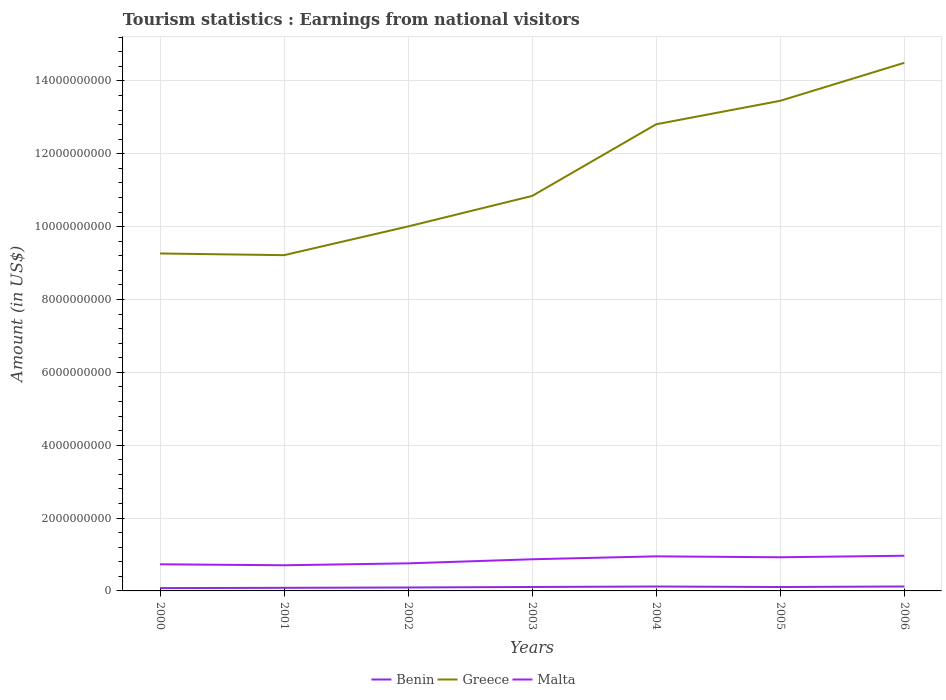Does the line corresponding to Malta intersect with the line corresponding to Benin?
Offer a terse response. No. Across all years, what is the maximum earnings from national visitors in Greece?
Provide a short and direct response. 9.22e+09. In which year was the earnings from national visitors in Benin maximum?
Provide a short and direct response. 2000. What is the total earnings from national visitors in Benin in the graph?
Your answer should be very brief. -3.61e+07. What is the difference between the highest and the second highest earnings from national visitors in Benin?
Your response must be concise. 4.42e+07. What is the difference between the highest and the lowest earnings from national visitors in Malta?
Your answer should be compact. 4. How many years are there in the graph?
Give a very brief answer. 7. What is the difference between two consecutive major ticks on the Y-axis?
Offer a terse response. 2.00e+09. Are the values on the major ticks of Y-axis written in scientific E-notation?
Make the answer very short. No. Does the graph contain any zero values?
Give a very brief answer. No. How many legend labels are there?
Offer a very short reply. 3. How are the legend labels stacked?
Your response must be concise. Horizontal. What is the title of the graph?
Provide a succinct answer. Tourism statistics : Earnings from national visitors. What is the label or title of the X-axis?
Keep it short and to the point. Years. What is the Amount (in US$) in Benin in 2000?
Offer a very short reply. 7.74e+07. What is the Amount (in US$) of Greece in 2000?
Offer a terse response. 9.26e+09. What is the Amount (in US$) of Malta in 2000?
Keep it short and to the point. 7.31e+08. What is the Amount (in US$) in Benin in 2001?
Provide a short and direct response. 8.55e+07. What is the Amount (in US$) of Greece in 2001?
Your response must be concise. 9.22e+09. What is the Amount (in US$) in Malta in 2001?
Ensure brevity in your answer.  7.04e+08. What is the Amount (in US$) of Benin in 2002?
Make the answer very short. 9.45e+07. What is the Amount (in US$) in Greece in 2002?
Make the answer very short. 1.00e+1. What is the Amount (in US$) in Malta in 2002?
Your answer should be very brief. 7.57e+08. What is the Amount (in US$) in Benin in 2003?
Your answer should be very brief. 1.08e+08. What is the Amount (in US$) of Greece in 2003?
Give a very brief answer. 1.08e+1. What is the Amount (in US$) in Malta in 2003?
Make the answer very short. 8.69e+08. What is the Amount (in US$) in Benin in 2004?
Give a very brief answer. 1.21e+08. What is the Amount (in US$) of Greece in 2004?
Your answer should be compact. 1.28e+1. What is the Amount (in US$) in Malta in 2004?
Provide a succinct answer. 9.49e+08. What is the Amount (in US$) in Benin in 2005?
Make the answer very short. 1.08e+08. What is the Amount (in US$) in Greece in 2005?
Your response must be concise. 1.35e+1. What is the Amount (in US$) of Malta in 2005?
Offer a very short reply. 9.24e+08. What is the Amount (in US$) in Benin in 2006?
Your answer should be compact. 1.22e+08. What is the Amount (in US$) of Greece in 2006?
Provide a succinct answer. 1.45e+1. What is the Amount (in US$) of Malta in 2006?
Offer a terse response. 9.66e+08. Across all years, what is the maximum Amount (in US$) in Benin?
Ensure brevity in your answer.  1.22e+08. Across all years, what is the maximum Amount (in US$) in Greece?
Your answer should be compact. 1.45e+1. Across all years, what is the maximum Amount (in US$) of Malta?
Make the answer very short. 9.66e+08. Across all years, what is the minimum Amount (in US$) of Benin?
Your answer should be very brief. 7.74e+07. Across all years, what is the minimum Amount (in US$) of Greece?
Your response must be concise. 9.22e+09. Across all years, what is the minimum Amount (in US$) in Malta?
Ensure brevity in your answer.  7.04e+08. What is the total Amount (in US$) of Benin in the graph?
Provide a succinct answer. 7.16e+08. What is the total Amount (in US$) of Greece in the graph?
Make the answer very short. 8.01e+1. What is the total Amount (in US$) of Malta in the graph?
Ensure brevity in your answer.  5.90e+09. What is the difference between the Amount (in US$) in Benin in 2000 and that in 2001?
Your response must be concise. -8.10e+06. What is the difference between the Amount (in US$) in Greece in 2000 and that in 2001?
Keep it short and to the point. 4.60e+07. What is the difference between the Amount (in US$) of Malta in 2000 and that in 2001?
Make the answer very short. 2.70e+07. What is the difference between the Amount (in US$) of Benin in 2000 and that in 2002?
Provide a succinct answer. -1.71e+07. What is the difference between the Amount (in US$) in Greece in 2000 and that in 2002?
Make the answer very short. -7.43e+08. What is the difference between the Amount (in US$) of Malta in 2000 and that in 2002?
Make the answer very short. -2.60e+07. What is the difference between the Amount (in US$) of Benin in 2000 and that in 2003?
Your answer should be very brief. -3.05e+07. What is the difference between the Amount (in US$) in Greece in 2000 and that in 2003?
Keep it short and to the point. -1.58e+09. What is the difference between the Amount (in US$) in Malta in 2000 and that in 2003?
Your answer should be compact. -1.38e+08. What is the difference between the Amount (in US$) in Benin in 2000 and that in 2004?
Offer a terse response. -4.35e+07. What is the difference between the Amount (in US$) of Greece in 2000 and that in 2004?
Provide a succinct answer. -3.55e+09. What is the difference between the Amount (in US$) in Malta in 2000 and that in 2004?
Offer a terse response. -2.18e+08. What is the difference between the Amount (in US$) in Benin in 2000 and that in 2005?
Your answer should be compact. -3.03e+07. What is the difference between the Amount (in US$) in Greece in 2000 and that in 2005?
Offer a very short reply. -4.19e+09. What is the difference between the Amount (in US$) of Malta in 2000 and that in 2005?
Keep it short and to the point. -1.93e+08. What is the difference between the Amount (in US$) of Benin in 2000 and that in 2006?
Provide a short and direct response. -4.42e+07. What is the difference between the Amount (in US$) in Greece in 2000 and that in 2006?
Make the answer very short. -5.23e+09. What is the difference between the Amount (in US$) of Malta in 2000 and that in 2006?
Provide a short and direct response. -2.35e+08. What is the difference between the Amount (in US$) of Benin in 2001 and that in 2002?
Offer a terse response. -9.00e+06. What is the difference between the Amount (in US$) in Greece in 2001 and that in 2002?
Your answer should be very brief. -7.89e+08. What is the difference between the Amount (in US$) of Malta in 2001 and that in 2002?
Offer a terse response. -5.30e+07. What is the difference between the Amount (in US$) of Benin in 2001 and that in 2003?
Your answer should be compact. -2.24e+07. What is the difference between the Amount (in US$) of Greece in 2001 and that in 2003?
Ensure brevity in your answer.  -1.63e+09. What is the difference between the Amount (in US$) in Malta in 2001 and that in 2003?
Provide a short and direct response. -1.65e+08. What is the difference between the Amount (in US$) in Benin in 2001 and that in 2004?
Offer a very short reply. -3.54e+07. What is the difference between the Amount (in US$) in Greece in 2001 and that in 2004?
Keep it short and to the point. -3.59e+09. What is the difference between the Amount (in US$) in Malta in 2001 and that in 2004?
Offer a very short reply. -2.45e+08. What is the difference between the Amount (in US$) of Benin in 2001 and that in 2005?
Your response must be concise. -2.22e+07. What is the difference between the Amount (in US$) in Greece in 2001 and that in 2005?
Your answer should be compact. -4.24e+09. What is the difference between the Amount (in US$) of Malta in 2001 and that in 2005?
Offer a terse response. -2.20e+08. What is the difference between the Amount (in US$) of Benin in 2001 and that in 2006?
Your answer should be compact. -3.61e+07. What is the difference between the Amount (in US$) in Greece in 2001 and that in 2006?
Your answer should be compact. -5.28e+09. What is the difference between the Amount (in US$) in Malta in 2001 and that in 2006?
Provide a succinct answer. -2.62e+08. What is the difference between the Amount (in US$) in Benin in 2002 and that in 2003?
Offer a terse response. -1.34e+07. What is the difference between the Amount (in US$) in Greece in 2002 and that in 2003?
Offer a very short reply. -8.37e+08. What is the difference between the Amount (in US$) in Malta in 2002 and that in 2003?
Ensure brevity in your answer.  -1.12e+08. What is the difference between the Amount (in US$) in Benin in 2002 and that in 2004?
Provide a short and direct response. -2.64e+07. What is the difference between the Amount (in US$) of Greece in 2002 and that in 2004?
Your answer should be compact. -2.80e+09. What is the difference between the Amount (in US$) in Malta in 2002 and that in 2004?
Provide a short and direct response. -1.92e+08. What is the difference between the Amount (in US$) of Benin in 2002 and that in 2005?
Provide a short and direct response. -1.32e+07. What is the difference between the Amount (in US$) of Greece in 2002 and that in 2005?
Keep it short and to the point. -3.45e+09. What is the difference between the Amount (in US$) of Malta in 2002 and that in 2005?
Your answer should be very brief. -1.67e+08. What is the difference between the Amount (in US$) in Benin in 2002 and that in 2006?
Provide a succinct answer. -2.71e+07. What is the difference between the Amount (in US$) in Greece in 2002 and that in 2006?
Your answer should be very brief. -4.49e+09. What is the difference between the Amount (in US$) in Malta in 2002 and that in 2006?
Your response must be concise. -2.09e+08. What is the difference between the Amount (in US$) of Benin in 2003 and that in 2004?
Offer a very short reply. -1.30e+07. What is the difference between the Amount (in US$) of Greece in 2003 and that in 2004?
Offer a terse response. -1.97e+09. What is the difference between the Amount (in US$) in Malta in 2003 and that in 2004?
Your answer should be compact. -8.00e+07. What is the difference between the Amount (in US$) of Greece in 2003 and that in 2005?
Give a very brief answer. -2.61e+09. What is the difference between the Amount (in US$) of Malta in 2003 and that in 2005?
Your response must be concise. -5.50e+07. What is the difference between the Amount (in US$) of Benin in 2003 and that in 2006?
Provide a short and direct response. -1.37e+07. What is the difference between the Amount (in US$) of Greece in 2003 and that in 2006?
Your answer should be compact. -3.65e+09. What is the difference between the Amount (in US$) in Malta in 2003 and that in 2006?
Provide a succinct answer. -9.70e+07. What is the difference between the Amount (in US$) of Benin in 2004 and that in 2005?
Give a very brief answer. 1.32e+07. What is the difference between the Amount (in US$) in Greece in 2004 and that in 2005?
Make the answer very short. -6.44e+08. What is the difference between the Amount (in US$) of Malta in 2004 and that in 2005?
Offer a very short reply. 2.50e+07. What is the difference between the Amount (in US$) in Benin in 2004 and that in 2006?
Your answer should be very brief. -7.00e+05. What is the difference between the Amount (in US$) of Greece in 2004 and that in 2006?
Give a very brief answer. -1.69e+09. What is the difference between the Amount (in US$) of Malta in 2004 and that in 2006?
Provide a succinct answer. -1.70e+07. What is the difference between the Amount (in US$) of Benin in 2005 and that in 2006?
Give a very brief answer. -1.39e+07. What is the difference between the Amount (in US$) in Greece in 2005 and that in 2006?
Your answer should be compact. -1.04e+09. What is the difference between the Amount (in US$) in Malta in 2005 and that in 2006?
Offer a terse response. -4.20e+07. What is the difference between the Amount (in US$) of Benin in 2000 and the Amount (in US$) of Greece in 2001?
Give a very brief answer. -9.14e+09. What is the difference between the Amount (in US$) in Benin in 2000 and the Amount (in US$) in Malta in 2001?
Offer a very short reply. -6.27e+08. What is the difference between the Amount (in US$) in Greece in 2000 and the Amount (in US$) in Malta in 2001?
Make the answer very short. 8.56e+09. What is the difference between the Amount (in US$) in Benin in 2000 and the Amount (in US$) in Greece in 2002?
Provide a short and direct response. -9.93e+09. What is the difference between the Amount (in US$) of Benin in 2000 and the Amount (in US$) of Malta in 2002?
Offer a very short reply. -6.80e+08. What is the difference between the Amount (in US$) of Greece in 2000 and the Amount (in US$) of Malta in 2002?
Provide a short and direct response. 8.50e+09. What is the difference between the Amount (in US$) of Benin in 2000 and the Amount (in US$) of Greece in 2003?
Your answer should be compact. -1.08e+1. What is the difference between the Amount (in US$) in Benin in 2000 and the Amount (in US$) in Malta in 2003?
Your answer should be very brief. -7.92e+08. What is the difference between the Amount (in US$) of Greece in 2000 and the Amount (in US$) of Malta in 2003?
Provide a succinct answer. 8.39e+09. What is the difference between the Amount (in US$) in Benin in 2000 and the Amount (in US$) in Greece in 2004?
Offer a very short reply. -1.27e+1. What is the difference between the Amount (in US$) in Benin in 2000 and the Amount (in US$) in Malta in 2004?
Offer a very short reply. -8.72e+08. What is the difference between the Amount (in US$) of Greece in 2000 and the Amount (in US$) of Malta in 2004?
Provide a short and direct response. 8.31e+09. What is the difference between the Amount (in US$) of Benin in 2000 and the Amount (in US$) of Greece in 2005?
Offer a very short reply. -1.34e+1. What is the difference between the Amount (in US$) of Benin in 2000 and the Amount (in US$) of Malta in 2005?
Give a very brief answer. -8.47e+08. What is the difference between the Amount (in US$) in Greece in 2000 and the Amount (in US$) in Malta in 2005?
Make the answer very short. 8.34e+09. What is the difference between the Amount (in US$) in Benin in 2000 and the Amount (in US$) in Greece in 2006?
Keep it short and to the point. -1.44e+1. What is the difference between the Amount (in US$) of Benin in 2000 and the Amount (in US$) of Malta in 2006?
Provide a short and direct response. -8.89e+08. What is the difference between the Amount (in US$) of Greece in 2000 and the Amount (in US$) of Malta in 2006?
Provide a short and direct response. 8.30e+09. What is the difference between the Amount (in US$) of Benin in 2001 and the Amount (in US$) of Greece in 2002?
Provide a succinct answer. -9.92e+09. What is the difference between the Amount (in US$) in Benin in 2001 and the Amount (in US$) in Malta in 2002?
Offer a terse response. -6.72e+08. What is the difference between the Amount (in US$) of Greece in 2001 and the Amount (in US$) of Malta in 2002?
Offer a very short reply. 8.46e+09. What is the difference between the Amount (in US$) of Benin in 2001 and the Amount (in US$) of Greece in 2003?
Keep it short and to the point. -1.08e+1. What is the difference between the Amount (in US$) of Benin in 2001 and the Amount (in US$) of Malta in 2003?
Provide a succinct answer. -7.84e+08. What is the difference between the Amount (in US$) of Greece in 2001 and the Amount (in US$) of Malta in 2003?
Your answer should be very brief. 8.35e+09. What is the difference between the Amount (in US$) of Benin in 2001 and the Amount (in US$) of Greece in 2004?
Offer a terse response. -1.27e+1. What is the difference between the Amount (in US$) in Benin in 2001 and the Amount (in US$) in Malta in 2004?
Give a very brief answer. -8.64e+08. What is the difference between the Amount (in US$) of Greece in 2001 and the Amount (in US$) of Malta in 2004?
Ensure brevity in your answer.  8.27e+09. What is the difference between the Amount (in US$) of Benin in 2001 and the Amount (in US$) of Greece in 2005?
Your response must be concise. -1.34e+1. What is the difference between the Amount (in US$) of Benin in 2001 and the Amount (in US$) of Malta in 2005?
Your response must be concise. -8.38e+08. What is the difference between the Amount (in US$) in Greece in 2001 and the Amount (in US$) in Malta in 2005?
Make the answer very short. 8.29e+09. What is the difference between the Amount (in US$) in Benin in 2001 and the Amount (in US$) in Greece in 2006?
Your answer should be compact. -1.44e+1. What is the difference between the Amount (in US$) of Benin in 2001 and the Amount (in US$) of Malta in 2006?
Your answer should be compact. -8.80e+08. What is the difference between the Amount (in US$) of Greece in 2001 and the Amount (in US$) of Malta in 2006?
Offer a very short reply. 8.25e+09. What is the difference between the Amount (in US$) of Benin in 2002 and the Amount (in US$) of Greece in 2003?
Ensure brevity in your answer.  -1.07e+1. What is the difference between the Amount (in US$) in Benin in 2002 and the Amount (in US$) in Malta in 2003?
Offer a terse response. -7.74e+08. What is the difference between the Amount (in US$) of Greece in 2002 and the Amount (in US$) of Malta in 2003?
Offer a very short reply. 9.14e+09. What is the difference between the Amount (in US$) of Benin in 2002 and the Amount (in US$) of Greece in 2004?
Your answer should be very brief. -1.27e+1. What is the difference between the Amount (in US$) in Benin in 2002 and the Amount (in US$) in Malta in 2004?
Offer a terse response. -8.54e+08. What is the difference between the Amount (in US$) in Greece in 2002 and the Amount (in US$) in Malta in 2004?
Make the answer very short. 9.06e+09. What is the difference between the Amount (in US$) in Benin in 2002 and the Amount (in US$) in Greece in 2005?
Make the answer very short. -1.34e+1. What is the difference between the Amount (in US$) of Benin in 2002 and the Amount (in US$) of Malta in 2005?
Provide a short and direct response. -8.30e+08. What is the difference between the Amount (in US$) of Greece in 2002 and the Amount (in US$) of Malta in 2005?
Make the answer very short. 9.08e+09. What is the difference between the Amount (in US$) in Benin in 2002 and the Amount (in US$) in Greece in 2006?
Provide a short and direct response. -1.44e+1. What is the difference between the Amount (in US$) of Benin in 2002 and the Amount (in US$) of Malta in 2006?
Keep it short and to the point. -8.72e+08. What is the difference between the Amount (in US$) of Greece in 2002 and the Amount (in US$) of Malta in 2006?
Your response must be concise. 9.04e+09. What is the difference between the Amount (in US$) of Benin in 2003 and the Amount (in US$) of Greece in 2004?
Your answer should be very brief. -1.27e+1. What is the difference between the Amount (in US$) of Benin in 2003 and the Amount (in US$) of Malta in 2004?
Your answer should be compact. -8.41e+08. What is the difference between the Amount (in US$) in Greece in 2003 and the Amount (in US$) in Malta in 2004?
Provide a succinct answer. 9.89e+09. What is the difference between the Amount (in US$) in Benin in 2003 and the Amount (in US$) in Greece in 2005?
Offer a very short reply. -1.33e+1. What is the difference between the Amount (in US$) in Benin in 2003 and the Amount (in US$) in Malta in 2005?
Provide a short and direct response. -8.16e+08. What is the difference between the Amount (in US$) of Greece in 2003 and the Amount (in US$) of Malta in 2005?
Your answer should be compact. 9.92e+09. What is the difference between the Amount (in US$) in Benin in 2003 and the Amount (in US$) in Greece in 2006?
Make the answer very short. -1.44e+1. What is the difference between the Amount (in US$) of Benin in 2003 and the Amount (in US$) of Malta in 2006?
Offer a terse response. -8.58e+08. What is the difference between the Amount (in US$) of Greece in 2003 and the Amount (in US$) of Malta in 2006?
Offer a very short reply. 9.88e+09. What is the difference between the Amount (in US$) of Benin in 2004 and the Amount (in US$) of Greece in 2005?
Keep it short and to the point. -1.33e+1. What is the difference between the Amount (in US$) in Benin in 2004 and the Amount (in US$) in Malta in 2005?
Ensure brevity in your answer.  -8.03e+08. What is the difference between the Amount (in US$) in Greece in 2004 and the Amount (in US$) in Malta in 2005?
Your answer should be compact. 1.19e+1. What is the difference between the Amount (in US$) in Benin in 2004 and the Amount (in US$) in Greece in 2006?
Your answer should be very brief. -1.44e+1. What is the difference between the Amount (in US$) in Benin in 2004 and the Amount (in US$) in Malta in 2006?
Keep it short and to the point. -8.45e+08. What is the difference between the Amount (in US$) of Greece in 2004 and the Amount (in US$) of Malta in 2006?
Provide a short and direct response. 1.18e+1. What is the difference between the Amount (in US$) of Benin in 2005 and the Amount (in US$) of Greece in 2006?
Ensure brevity in your answer.  -1.44e+1. What is the difference between the Amount (in US$) in Benin in 2005 and the Amount (in US$) in Malta in 2006?
Provide a short and direct response. -8.58e+08. What is the difference between the Amount (in US$) in Greece in 2005 and the Amount (in US$) in Malta in 2006?
Provide a succinct answer. 1.25e+1. What is the average Amount (in US$) of Benin per year?
Ensure brevity in your answer.  1.02e+08. What is the average Amount (in US$) of Greece per year?
Your response must be concise. 1.14e+1. What is the average Amount (in US$) of Malta per year?
Provide a short and direct response. 8.43e+08. In the year 2000, what is the difference between the Amount (in US$) of Benin and Amount (in US$) of Greece?
Make the answer very short. -9.18e+09. In the year 2000, what is the difference between the Amount (in US$) of Benin and Amount (in US$) of Malta?
Keep it short and to the point. -6.54e+08. In the year 2000, what is the difference between the Amount (in US$) of Greece and Amount (in US$) of Malta?
Offer a terse response. 8.53e+09. In the year 2001, what is the difference between the Amount (in US$) of Benin and Amount (in US$) of Greece?
Make the answer very short. -9.13e+09. In the year 2001, what is the difference between the Amount (in US$) in Benin and Amount (in US$) in Malta?
Provide a succinct answer. -6.18e+08. In the year 2001, what is the difference between the Amount (in US$) in Greece and Amount (in US$) in Malta?
Offer a terse response. 8.51e+09. In the year 2002, what is the difference between the Amount (in US$) of Benin and Amount (in US$) of Greece?
Your answer should be very brief. -9.91e+09. In the year 2002, what is the difference between the Amount (in US$) in Benin and Amount (in US$) in Malta?
Make the answer very short. -6.62e+08. In the year 2002, what is the difference between the Amount (in US$) in Greece and Amount (in US$) in Malta?
Provide a succinct answer. 9.25e+09. In the year 2003, what is the difference between the Amount (in US$) of Benin and Amount (in US$) of Greece?
Provide a short and direct response. -1.07e+1. In the year 2003, what is the difference between the Amount (in US$) of Benin and Amount (in US$) of Malta?
Your answer should be very brief. -7.61e+08. In the year 2003, what is the difference between the Amount (in US$) in Greece and Amount (in US$) in Malta?
Give a very brief answer. 9.97e+09. In the year 2004, what is the difference between the Amount (in US$) of Benin and Amount (in US$) of Greece?
Provide a short and direct response. -1.27e+1. In the year 2004, what is the difference between the Amount (in US$) in Benin and Amount (in US$) in Malta?
Offer a very short reply. -8.28e+08. In the year 2004, what is the difference between the Amount (in US$) in Greece and Amount (in US$) in Malta?
Provide a succinct answer. 1.19e+1. In the year 2005, what is the difference between the Amount (in US$) of Benin and Amount (in US$) of Greece?
Keep it short and to the point. -1.33e+1. In the year 2005, what is the difference between the Amount (in US$) in Benin and Amount (in US$) in Malta?
Your answer should be compact. -8.16e+08. In the year 2005, what is the difference between the Amount (in US$) in Greece and Amount (in US$) in Malta?
Offer a terse response. 1.25e+1. In the year 2006, what is the difference between the Amount (in US$) in Benin and Amount (in US$) in Greece?
Keep it short and to the point. -1.44e+1. In the year 2006, what is the difference between the Amount (in US$) in Benin and Amount (in US$) in Malta?
Offer a terse response. -8.44e+08. In the year 2006, what is the difference between the Amount (in US$) of Greece and Amount (in US$) of Malta?
Give a very brief answer. 1.35e+1. What is the ratio of the Amount (in US$) of Benin in 2000 to that in 2001?
Provide a succinct answer. 0.91. What is the ratio of the Amount (in US$) of Malta in 2000 to that in 2001?
Keep it short and to the point. 1.04. What is the ratio of the Amount (in US$) in Benin in 2000 to that in 2002?
Make the answer very short. 0.82. What is the ratio of the Amount (in US$) of Greece in 2000 to that in 2002?
Your response must be concise. 0.93. What is the ratio of the Amount (in US$) of Malta in 2000 to that in 2002?
Provide a short and direct response. 0.97. What is the ratio of the Amount (in US$) in Benin in 2000 to that in 2003?
Make the answer very short. 0.72. What is the ratio of the Amount (in US$) in Greece in 2000 to that in 2003?
Ensure brevity in your answer.  0.85. What is the ratio of the Amount (in US$) in Malta in 2000 to that in 2003?
Provide a short and direct response. 0.84. What is the ratio of the Amount (in US$) in Benin in 2000 to that in 2004?
Your answer should be very brief. 0.64. What is the ratio of the Amount (in US$) of Greece in 2000 to that in 2004?
Offer a terse response. 0.72. What is the ratio of the Amount (in US$) in Malta in 2000 to that in 2004?
Your answer should be compact. 0.77. What is the ratio of the Amount (in US$) in Benin in 2000 to that in 2005?
Your response must be concise. 0.72. What is the ratio of the Amount (in US$) of Greece in 2000 to that in 2005?
Keep it short and to the point. 0.69. What is the ratio of the Amount (in US$) in Malta in 2000 to that in 2005?
Make the answer very short. 0.79. What is the ratio of the Amount (in US$) of Benin in 2000 to that in 2006?
Provide a short and direct response. 0.64. What is the ratio of the Amount (in US$) in Greece in 2000 to that in 2006?
Ensure brevity in your answer.  0.64. What is the ratio of the Amount (in US$) of Malta in 2000 to that in 2006?
Provide a succinct answer. 0.76. What is the ratio of the Amount (in US$) in Benin in 2001 to that in 2002?
Your response must be concise. 0.9. What is the ratio of the Amount (in US$) of Greece in 2001 to that in 2002?
Make the answer very short. 0.92. What is the ratio of the Amount (in US$) of Benin in 2001 to that in 2003?
Provide a short and direct response. 0.79. What is the ratio of the Amount (in US$) in Greece in 2001 to that in 2003?
Keep it short and to the point. 0.85. What is the ratio of the Amount (in US$) in Malta in 2001 to that in 2003?
Provide a succinct answer. 0.81. What is the ratio of the Amount (in US$) of Benin in 2001 to that in 2004?
Your response must be concise. 0.71. What is the ratio of the Amount (in US$) in Greece in 2001 to that in 2004?
Keep it short and to the point. 0.72. What is the ratio of the Amount (in US$) in Malta in 2001 to that in 2004?
Offer a terse response. 0.74. What is the ratio of the Amount (in US$) in Benin in 2001 to that in 2005?
Keep it short and to the point. 0.79. What is the ratio of the Amount (in US$) of Greece in 2001 to that in 2005?
Provide a short and direct response. 0.69. What is the ratio of the Amount (in US$) of Malta in 2001 to that in 2005?
Give a very brief answer. 0.76. What is the ratio of the Amount (in US$) in Benin in 2001 to that in 2006?
Your response must be concise. 0.7. What is the ratio of the Amount (in US$) of Greece in 2001 to that in 2006?
Make the answer very short. 0.64. What is the ratio of the Amount (in US$) in Malta in 2001 to that in 2006?
Your answer should be compact. 0.73. What is the ratio of the Amount (in US$) in Benin in 2002 to that in 2003?
Make the answer very short. 0.88. What is the ratio of the Amount (in US$) in Greece in 2002 to that in 2003?
Provide a short and direct response. 0.92. What is the ratio of the Amount (in US$) in Malta in 2002 to that in 2003?
Your answer should be very brief. 0.87. What is the ratio of the Amount (in US$) in Benin in 2002 to that in 2004?
Offer a very short reply. 0.78. What is the ratio of the Amount (in US$) of Greece in 2002 to that in 2004?
Your response must be concise. 0.78. What is the ratio of the Amount (in US$) in Malta in 2002 to that in 2004?
Offer a terse response. 0.8. What is the ratio of the Amount (in US$) in Benin in 2002 to that in 2005?
Make the answer very short. 0.88. What is the ratio of the Amount (in US$) in Greece in 2002 to that in 2005?
Offer a terse response. 0.74. What is the ratio of the Amount (in US$) of Malta in 2002 to that in 2005?
Keep it short and to the point. 0.82. What is the ratio of the Amount (in US$) in Benin in 2002 to that in 2006?
Offer a terse response. 0.78. What is the ratio of the Amount (in US$) in Greece in 2002 to that in 2006?
Give a very brief answer. 0.69. What is the ratio of the Amount (in US$) of Malta in 2002 to that in 2006?
Offer a very short reply. 0.78. What is the ratio of the Amount (in US$) in Benin in 2003 to that in 2004?
Offer a terse response. 0.89. What is the ratio of the Amount (in US$) in Greece in 2003 to that in 2004?
Your answer should be very brief. 0.85. What is the ratio of the Amount (in US$) in Malta in 2003 to that in 2004?
Keep it short and to the point. 0.92. What is the ratio of the Amount (in US$) in Benin in 2003 to that in 2005?
Your answer should be compact. 1. What is the ratio of the Amount (in US$) in Greece in 2003 to that in 2005?
Your response must be concise. 0.81. What is the ratio of the Amount (in US$) in Malta in 2003 to that in 2005?
Offer a very short reply. 0.94. What is the ratio of the Amount (in US$) in Benin in 2003 to that in 2006?
Your answer should be compact. 0.89. What is the ratio of the Amount (in US$) of Greece in 2003 to that in 2006?
Your answer should be very brief. 0.75. What is the ratio of the Amount (in US$) in Malta in 2003 to that in 2006?
Your answer should be compact. 0.9. What is the ratio of the Amount (in US$) of Benin in 2004 to that in 2005?
Give a very brief answer. 1.12. What is the ratio of the Amount (in US$) in Greece in 2004 to that in 2005?
Your response must be concise. 0.95. What is the ratio of the Amount (in US$) of Malta in 2004 to that in 2005?
Your answer should be compact. 1.03. What is the ratio of the Amount (in US$) in Benin in 2004 to that in 2006?
Your answer should be compact. 0.99. What is the ratio of the Amount (in US$) of Greece in 2004 to that in 2006?
Your answer should be compact. 0.88. What is the ratio of the Amount (in US$) in Malta in 2004 to that in 2006?
Your answer should be very brief. 0.98. What is the ratio of the Amount (in US$) in Benin in 2005 to that in 2006?
Provide a short and direct response. 0.89. What is the ratio of the Amount (in US$) in Greece in 2005 to that in 2006?
Your answer should be compact. 0.93. What is the ratio of the Amount (in US$) of Malta in 2005 to that in 2006?
Give a very brief answer. 0.96. What is the difference between the highest and the second highest Amount (in US$) in Greece?
Offer a very short reply. 1.04e+09. What is the difference between the highest and the second highest Amount (in US$) of Malta?
Provide a succinct answer. 1.70e+07. What is the difference between the highest and the lowest Amount (in US$) in Benin?
Ensure brevity in your answer.  4.42e+07. What is the difference between the highest and the lowest Amount (in US$) in Greece?
Your response must be concise. 5.28e+09. What is the difference between the highest and the lowest Amount (in US$) in Malta?
Your answer should be compact. 2.62e+08. 